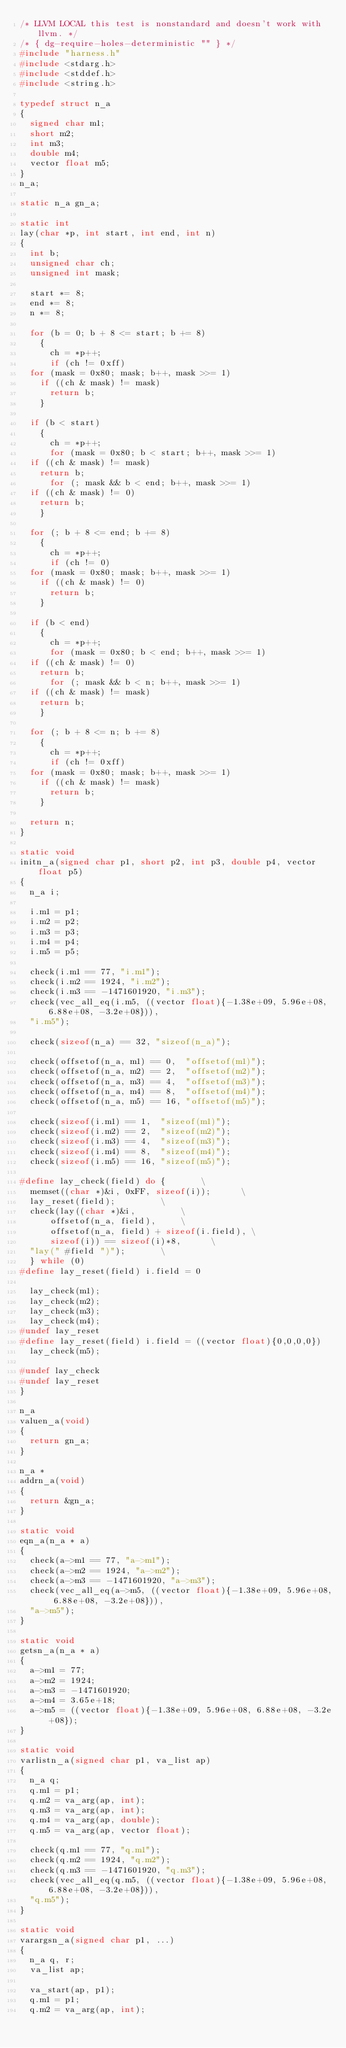Convert code to text. <code><loc_0><loc_0><loc_500><loc_500><_C_>/* LLVM LOCAL this test is nonstandard and doesn't work with llvm. */
/* { dg-require-holes-deterministic "" } */
#include "harness.h"
#include <stdarg.h>
#include <stddef.h>
#include <string.h>

typedef struct n_a
{
  signed char m1;
  short m2;
  int m3;
  double m4;
  vector float m5;
}
n_a;

static n_a gn_a;

static int
lay(char *p, int start, int end, int n)
{
  int b;
  unsigned char ch;
  unsigned int mask;

  start *= 8;
  end *= 8;
  n *= 8;

  for (b = 0; b + 8 <= start; b += 8)
    {
      ch = *p++;
      if (ch != 0xff)
	for (mask = 0x80; mask; b++, mask >>= 1)
	  if ((ch & mask) != mask)
	    return b;
    }

  if (b < start)
    {
      ch = *p++;
      for (mask = 0x80; b < start; b++, mask >>= 1)
	if ((ch & mask) != mask)
	  return b;
      for (; mask && b < end; b++, mask >>= 1)
	if ((ch & mask) != 0)
	  return b;
    }

  for (; b + 8 <= end; b += 8)
    {
      ch = *p++;
      if (ch != 0)
	for (mask = 0x80; mask; b++, mask >>= 1)
	  if ((ch & mask) != 0)
	    return b;
    }

  if (b < end)
    {
      ch = *p++;
      for (mask = 0x80; b < end; b++, mask >>= 1)
	if ((ch & mask) != 0)
	  return b;
      for (; mask && b < n; b++, mask >>= 1)
	if ((ch & mask) != mask)
	  return b;
    }

  for (; b + 8 <= n; b += 8)
    {
      ch = *p++;
      if (ch != 0xff)
	for (mask = 0x80; mask; b++, mask >>= 1)
	  if ((ch & mask) != mask)
	    return b;
    }

  return n;
}

static void
initn_a(signed char p1, short p2, int p3, double p4, vector float p5)
{
  n_a i;

  i.m1 = p1;
  i.m2 = p2;
  i.m3 = p3;
  i.m4 = p4;
  i.m5 = p5;

  check(i.m1 == 77, "i.m1");
  check(i.m2 == 1924, "i.m2");
  check(i.m3 == -1471601920, "i.m3");
  check(vec_all_eq(i.m5, ((vector float){-1.38e+09, 5.96e+08, 6.88e+08, -3.2e+08})),
	"i.m5");

  check(sizeof(n_a) == 32, "sizeof(n_a)");

  check(offsetof(n_a, m1) == 0,  "offsetof(m1)");
  check(offsetof(n_a, m2) == 2,  "offsetof(m2)");
  check(offsetof(n_a, m3) == 4,  "offsetof(m3)");
  check(offsetof(n_a, m4) == 8,  "offsetof(m4)");
  check(offsetof(n_a, m5) == 16, "offsetof(m5)");

  check(sizeof(i.m1) == 1,  "sizeof(m1)");
  check(sizeof(i.m2) == 2,  "sizeof(m2)");
  check(sizeof(i.m3) == 4,  "sizeof(m3)");
  check(sizeof(i.m4) == 8,  "sizeof(m4)");
  check(sizeof(i.m5) == 16, "sizeof(m5)");

#define lay_check(field) do {				\
  memset((char *)&i, 0xFF, sizeof(i));			\
  lay_reset(field);					\
  check(lay((char *)&i,					\
	    offsetof(n_a, field),			\
	    offsetof(n_a, field) + sizeof(i.field),	\
	    sizeof(i)) == sizeof(i)*8,			\
	"lay(" #field ")");				\
  } while (0)
#define lay_reset(field) i.field = 0

  lay_check(m1);
  lay_check(m2);
  lay_check(m3);
  lay_check(m4);
#undef lay_reset
#define lay_reset(field) i.field = ((vector float){0,0,0,0})
  lay_check(m5);

#undef lay_check
#undef lay_reset
}

n_a
valuen_a(void)
{
  return gn_a;
}

n_a *
addrn_a(void)
{
  return &gn_a;
}

static void
eqn_a(n_a * a)
{
  check(a->m1 == 77, "a->m1");
  check(a->m2 == 1924, "a->m2");
  check(a->m3 == -1471601920, "a->m3");
  check(vec_all_eq(a->m5, ((vector float){-1.38e+09, 5.96e+08, 6.88e+08, -3.2e+08})),
	"a->m5");
}

static void
getsn_a(n_a * a)
{
  a->m1 = 77;
  a->m2 = 1924;
  a->m3 = -1471601920;
  a->m4 = 3.65e+18;
  a->m5 = ((vector float){-1.38e+09, 5.96e+08, 6.88e+08, -3.2e+08});
}

static void
varlistn_a(signed char p1, va_list ap)
{
  n_a q;
  q.m1 = p1;
  q.m2 = va_arg(ap, int);
  q.m3 = va_arg(ap, int);
  q.m4 = va_arg(ap, double);
  q.m5 = va_arg(ap, vector float);

  check(q.m1 == 77, "q.m1");
  check(q.m2 == 1924, "q.m2");
  check(q.m3 == -1471601920, "q.m3");
  check(vec_all_eq(q.m5, ((vector float){-1.38e+09, 5.96e+08, 6.88e+08, -3.2e+08})),
	"q.m5");
}

static void
varargsn_a(signed char p1, ...)
{
  n_a q, r;
  va_list ap;

  va_start(ap, p1);
  q.m1 = p1;
  q.m2 = va_arg(ap, int);</code> 